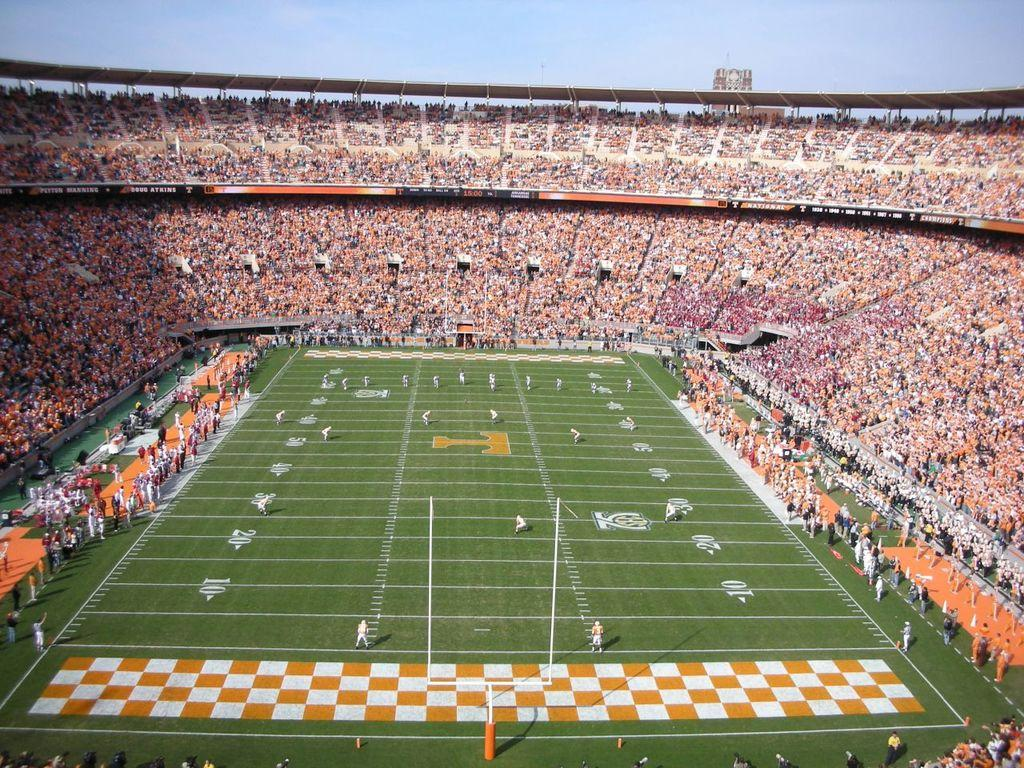<image>
Relay a brief, clear account of the picture shown. An orange T is at the center of the football field. 